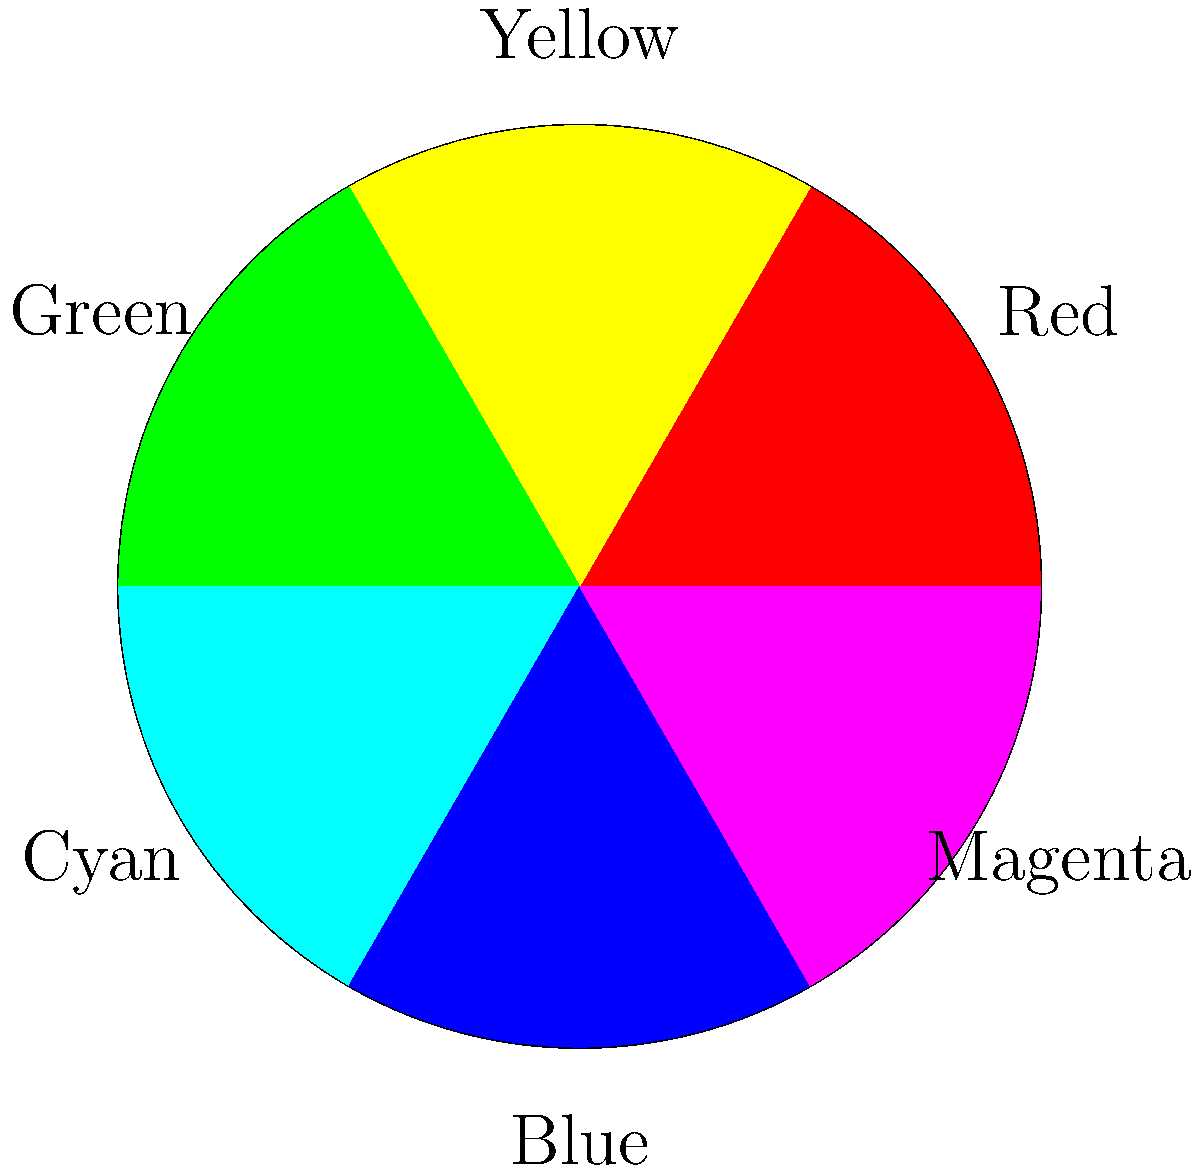In your experimental film collage, you want to create a striking visual contrast using complementary colors. Based on the color wheel shown, which color would you pair with yellow to achieve the strongest complementary effect? To determine the complementary color for yellow, we need to follow these steps:

1. Locate yellow on the color wheel (it's in the upper right segment).
2. Identify the color directly opposite yellow on the wheel.
3. The color wheel is divided into six main colors: red, yellow, green, cyan, blue, and magenta.
4. Yellow is positioned at approximately 90 degrees on the wheel.
5. The complementary color would be 180 degrees away from yellow, which is at 270 degrees.
6. At 270 degrees, we find the color blue.

In color theory, complementary colors are pairs of colors that are opposite each other on the color wheel. When used together, they create the strongest contrast and can make each other appear brighter and more vibrant. This principle is particularly useful in experimental filmmaking and collage techniques to create visually striking and impactful compositions.

By pairing yellow with blue in your film collage, you would achieve the most dramatic complementary effect, potentially enhancing the visual impact of your experimental cinema piece.
Answer: Blue 